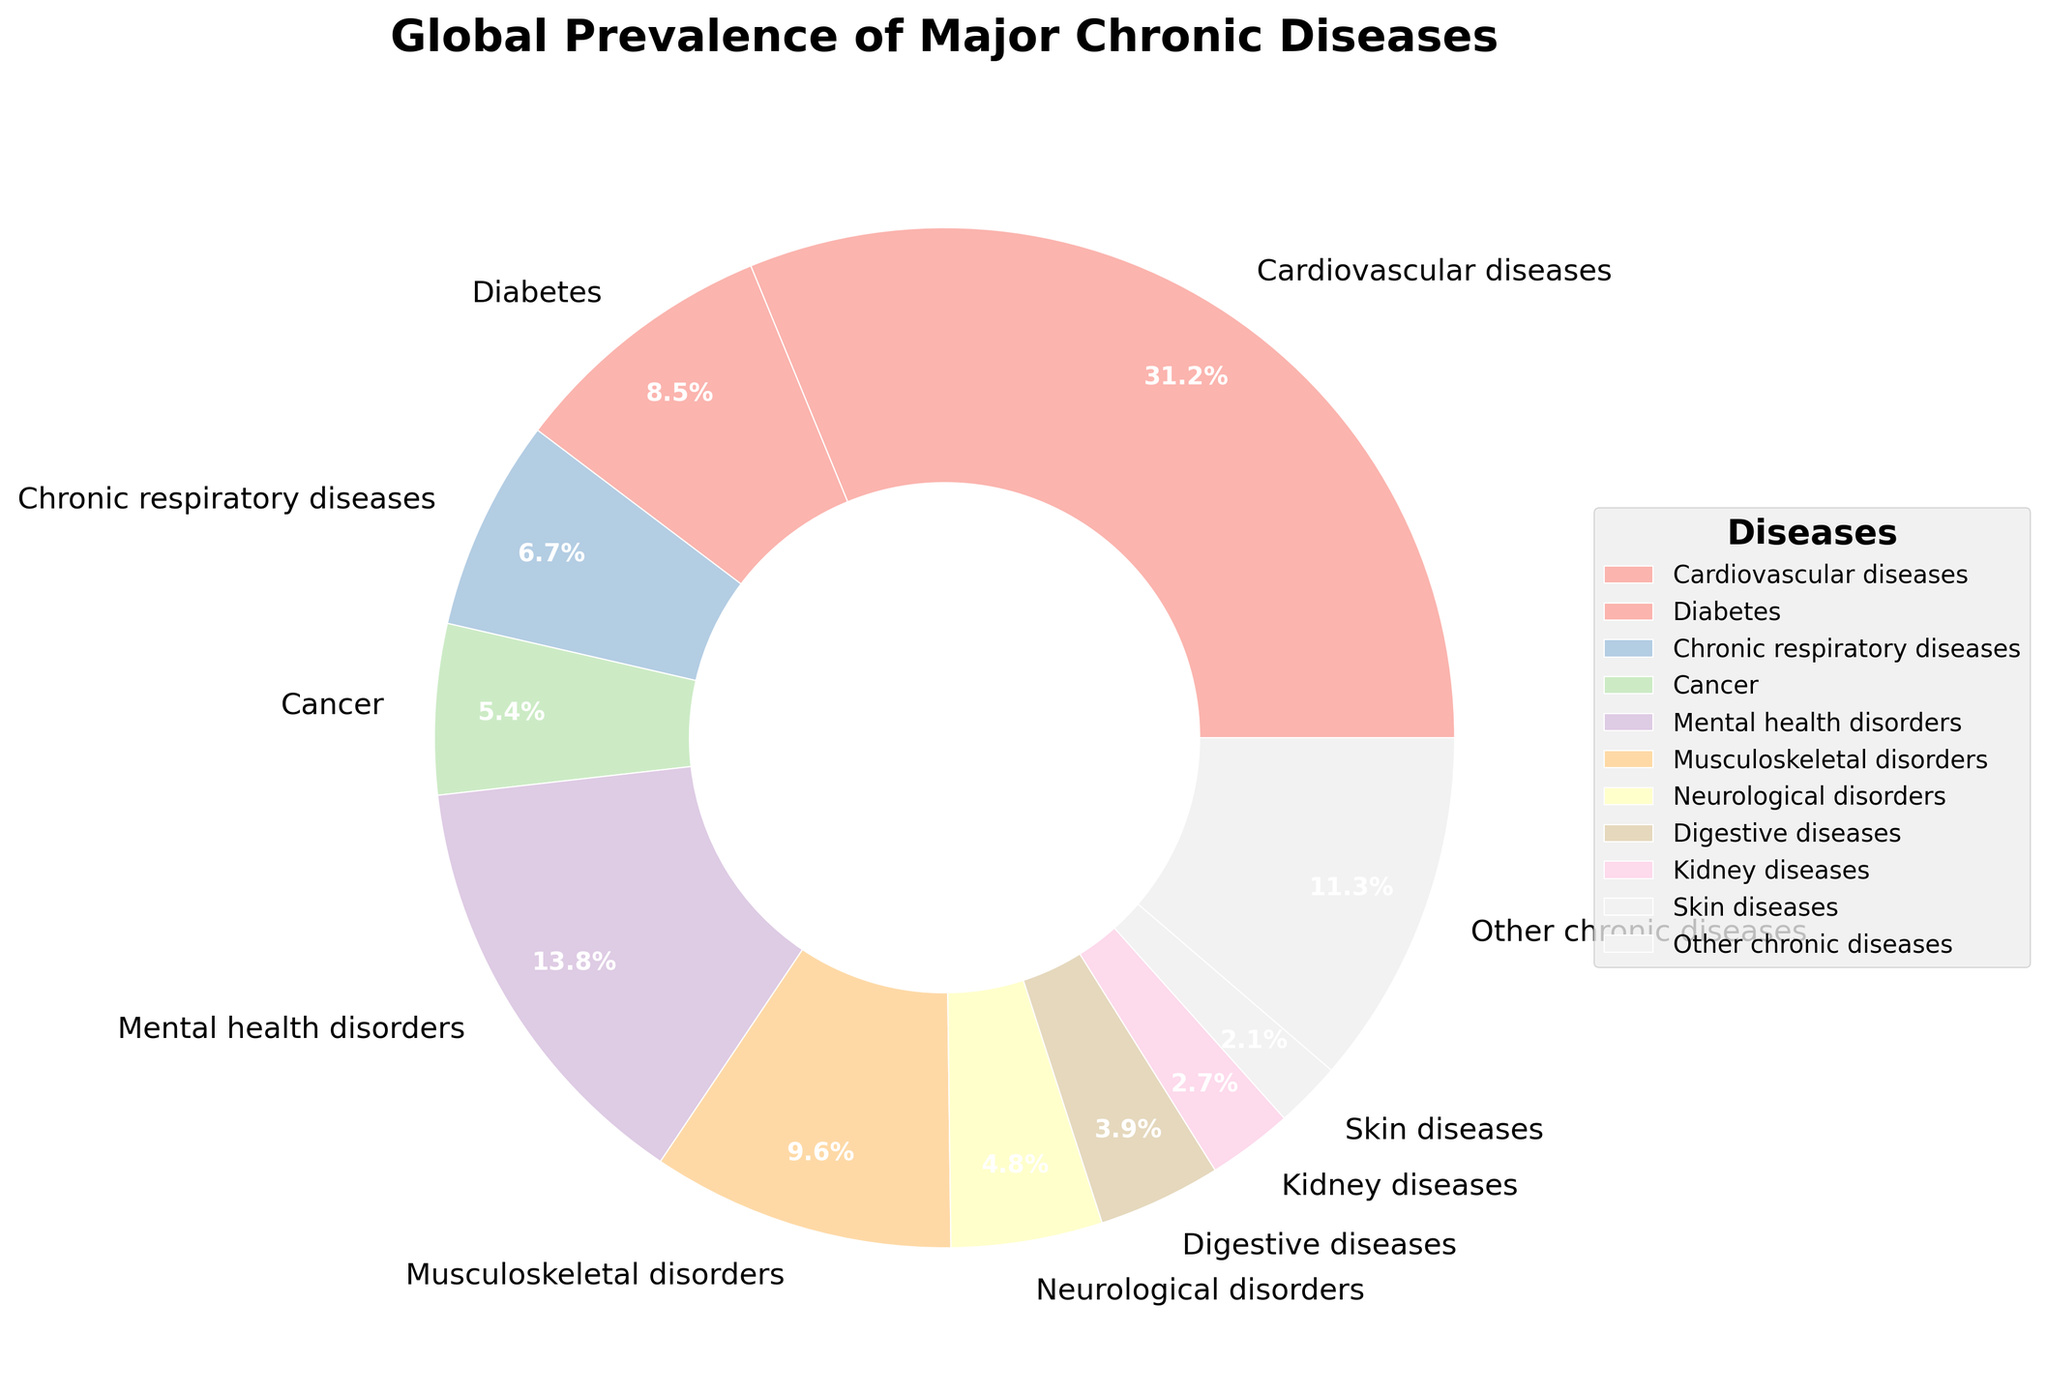What chronic disease has the highest global prevalence shown in the pie chart? The pie chart shows different diseases and their prevalence percentages. By identifying the largest slice, we can determine that cardiovascular diseases, with 31.2%, have the highest global prevalence.
Answer: Cardiovascular diseases How does the prevalence of chronic respiratory diseases compare to that of cancer? To compare, we look at the prevalence values: chronic respiratory diseases have 6.7%, and cancer has 5.4%. Chronic respiratory diseases have a slightly higher prevalence than cancer.
Answer: Chronic respiratory diseases have higher prevalence What is the total prevalence percentage of mental health disorders combined with musculoskeletal disorders? The prevalence of mental health disorders is 13.8%, and musculoskeletal disorders is 9.6%. Adding these together gives 13.8 + 9.6 = 23.4%.
Answer: 23.4% Which disease has a smaller prevalence: kidney diseases or digestive diseases? We compare the prevalence values of kidney diseases (2.7%) and digestive diseases (3.9%). Kidney diseases have a smaller prevalence.
Answer: Kidney diseases By how much does the prevalence of cardiovascular diseases exceed the prevalence of diabetes? Cardiovascular diseases have a prevalence of 31.2%, while diabetes has 8.5%. Subtracting these values, 31.2 - 8.5 = 22.7%.
Answer: 22.7% What is the combined prevalence of skin diseases and neurological disorders? The prevalence for skin diseases is 2.1%, and for neurological disorders, it is 4.8%. Adding these values, 2.1 + 4.8 = 6.9%.
Answer: 6.9% Which chronic disease has a prevalence closest to 10% without exceeding it? Observing the prevalence values, musculoskeletal disorders have a prevalence of 9.6%, which is closest to 10% without exceeding it.
Answer: Musculoskeletal disorders What is the average prevalence of cancer, neurological disorders, and kidney diseases? We add the prevalence values of cancer (5.4%), neurological disorders (4.8%), and kidney diseases (2.7%), and divide by the number of diseases: (5.4 + 4.8 + 2.7)/3 = 12.9/3 = 4.3%.
Answer: 4.3% What is the relative visual size difference between the pie slices of mental health disorders and skin diseases? The mental health disorders slice is noticeably larger than the skin diseases slice, as 13.8% is significantly greater than 2.1%.
Answer: Mental health disorders slice is larger Would combining the prevalence of digestive and kidney diseases surpass cancer's prevalence? Digestive diseases (3.9%) plus kidney diseases (2.7%) gives 3.9 + 2.7 = 6.6%, which is greater than cancer's 5.4%.
Answer: Yes 